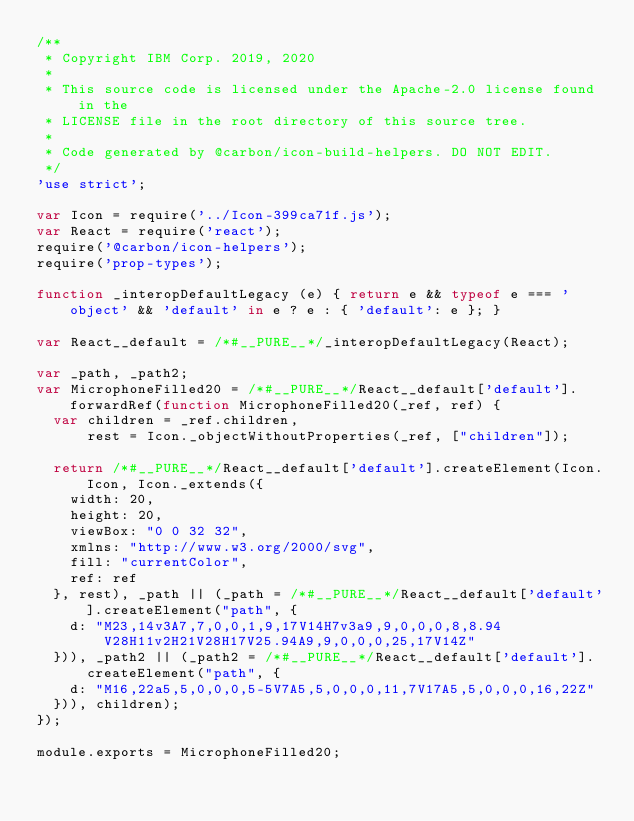<code> <loc_0><loc_0><loc_500><loc_500><_JavaScript_>/**
 * Copyright IBM Corp. 2019, 2020
 *
 * This source code is licensed under the Apache-2.0 license found in the
 * LICENSE file in the root directory of this source tree.
 *
 * Code generated by @carbon/icon-build-helpers. DO NOT EDIT.
 */
'use strict';

var Icon = require('../Icon-399ca71f.js');
var React = require('react');
require('@carbon/icon-helpers');
require('prop-types');

function _interopDefaultLegacy (e) { return e && typeof e === 'object' && 'default' in e ? e : { 'default': e }; }

var React__default = /*#__PURE__*/_interopDefaultLegacy(React);

var _path, _path2;
var MicrophoneFilled20 = /*#__PURE__*/React__default['default'].forwardRef(function MicrophoneFilled20(_ref, ref) {
  var children = _ref.children,
      rest = Icon._objectWithoutProperties(_ref, ["children"]);

  return /*#__PURE__*/React__default['default'].createElement(Icon.Icon, Icon._extends({
    width: 20,
    height: 20,
    viewBox: "0 0 32 32",
    xmlns: "http://www.w3.org/2000/svg",
    fill: "currentColor",
    ref: ref
  }, rest), _path || (_path = /*#__PURE__*/React__default['default'].createElement("path", {
    d: "M23,14v3A7,7,0,0,1,9,17V14H7v3a9,9,0,0,0,8,8.94V28H11v2H21V28H17V25.94A9,9,0,0,0,25,17V14Z"
  })), _path2 || (_path2 = /*#__PURE__*/React__default['default'].createElement("path", {
    d: "M16,22a5,5,0,0,0,5-5V7A5,5,0,0,0,11,7V17A5,5,0,0,0,16,22Z"
  })), children);
});

module.exports = MicrophoneFilled20;
</code> 